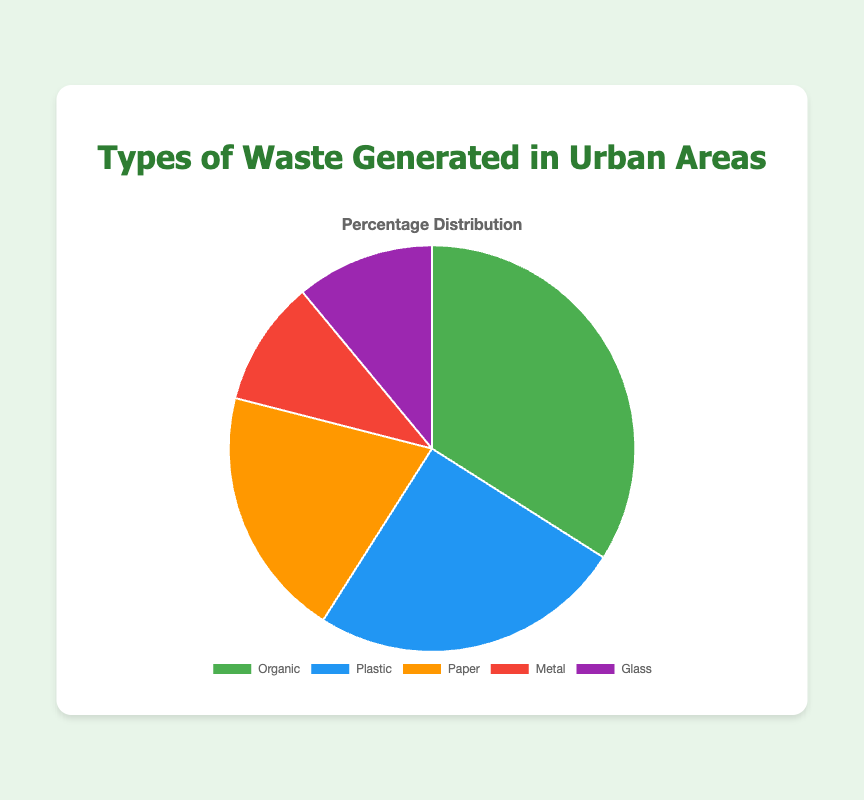What type of waste is generated the most in urban areas? Looking at the pie chart, the largest portion is labeled "Organic," indicating it makes up the largest percentage of waste generated in urban areas.
Answer: Organic Which type of waste is generated the least in urban areas? The smallest portion in the pie chart is labeled "Metal," indicating it makes up the smallest percentage of waste generated in urban areas.
Answer: Metal How much more organic waste is generated compared to metal waste? Organic waste is 34%, and metal waste is 10%. The difference is calculated as 34 - 10 = 24%.
Answer: 24% What is the combined percentage of plastic and paper waste? From the pie chart, plastic waste is 25% and paper waste is 20%. The combined percentage is 25 + 20 = 45%.
Answer: 45% Which types of waste together make up more than half of the total waste generated? The combined percentages of Organic (34%), Plastic (25%), and Paper (20%) need to be evaluated. Adding Organic and Plastic gives 34 + 25 = 59%, which is more than half. Therefore, Organic and Plastic together make up more than half.
Answer: Organic and Plastic How does the percentage of glass waste compare to paper waste? Glass waste is 11%, while paper waste is 20%. Thus, glass waste is less than paper waste by 20 - 11 = 9%.
Answer: Glass waste is 9% less than paper waste If the total urban waste is 1,000 tons, how many tons are plastic waste? If plastic waste is 25% of the total waste and the total is 1,000 tons, then plastic waste can be calculated as 25/100 * 1,000 = 250 tons.
Answer: 250 tons What proportion of the total waste is non-organic? Non-organic waste includes Plastic, Paper, Metal, and Glass. Adding these gives 25 + 20 + 10 + 11 = 66%.
Answer: 66% Is the percentage of metal waste closer to that of glass waste or paper waste? Metal waste is 10%, glass waste is 11% (difference = 1%), and paper waste is 20% (difference = 10%). Since 10% is closer to 11%, metal waste is closer to glass waste.
Answer: Glass waste 